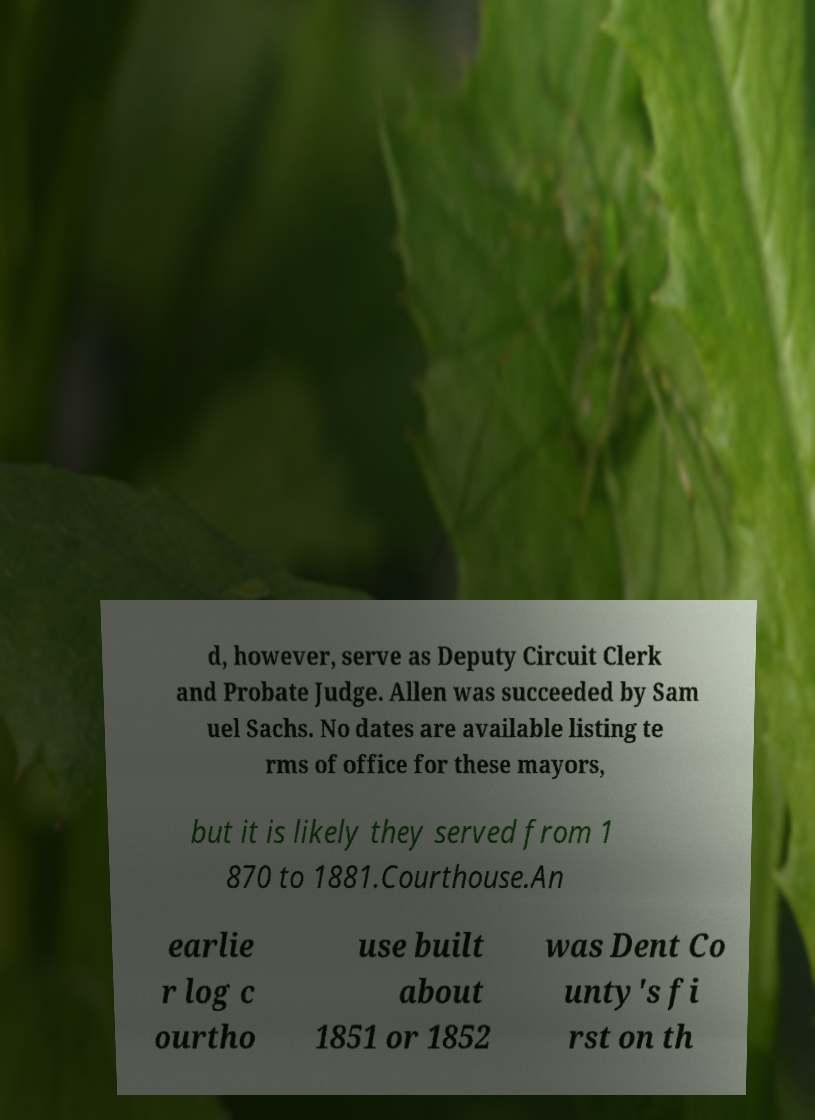I need the written content from this picture converted into text. Can you do that? d, however, serve as Deputy Circuit Clerk and Probate Judge. Allen was succeeded by Sam uel Sachs. No dates are available listing te rms of office for these mayors, but it is likely they served from 1 870 to 1881.Courthouse.An earlie r log c ourtho use built about 1851 or 1852 was Dent Co unty's fi rst on th 